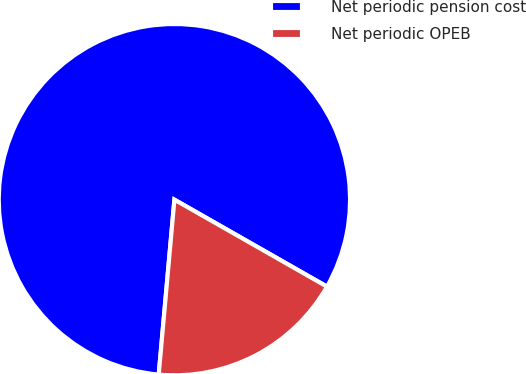Convert chart. <chart><loc_0><loc_0><loc_500><loc_500><pie_chart><fcel>Net periodic pension cost<fcel>Net periodic OPEB<nl><fcel>81.82%<fcel>18.18%<nl></chart> 